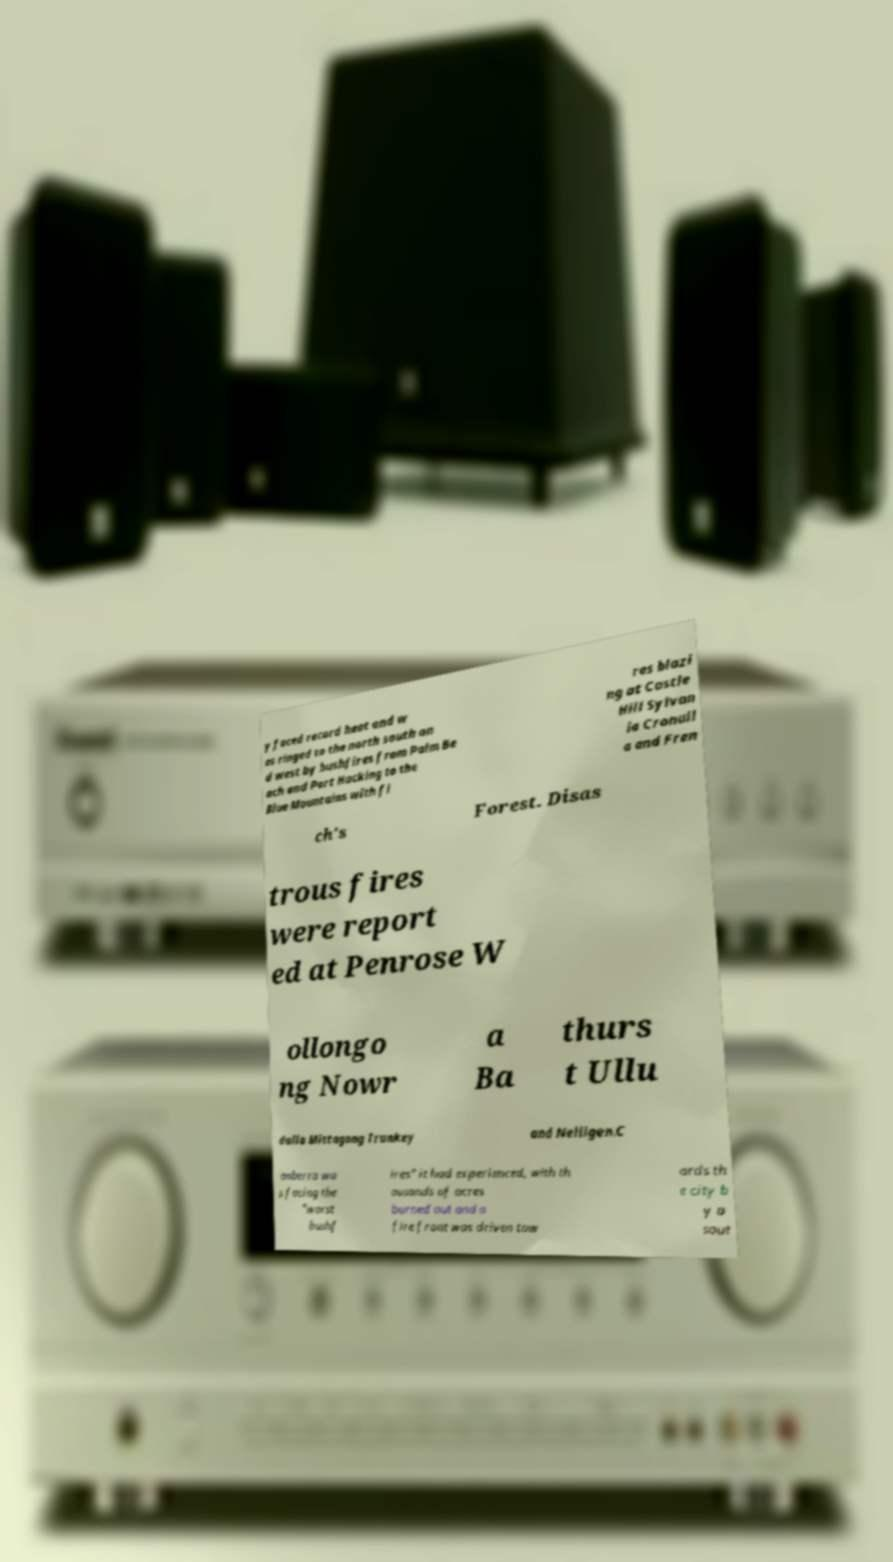Can you read and provide the text displayed in the image?This photo seems to have some interesting text. Can you extract and type it out for me? y faced record heat and w as ringed to the north south an d west by bushfires from Palm Be ach and Port Hacking to the Blue Mountains with fi res blazi ng at Castle Hill Sylvan ia Cronull a and Fren ch's Forest. Disas trous fires were report ed at Penrose W ollongo ng Nowr a Ba thurs t Ullu dulla Mittagong Trunkey and Nelligen.C anberra wa s facing the "worst bushf ires" it had experienced, with th ousands of acres burned out and a fire front was driven tow ards th e city b y a sout 